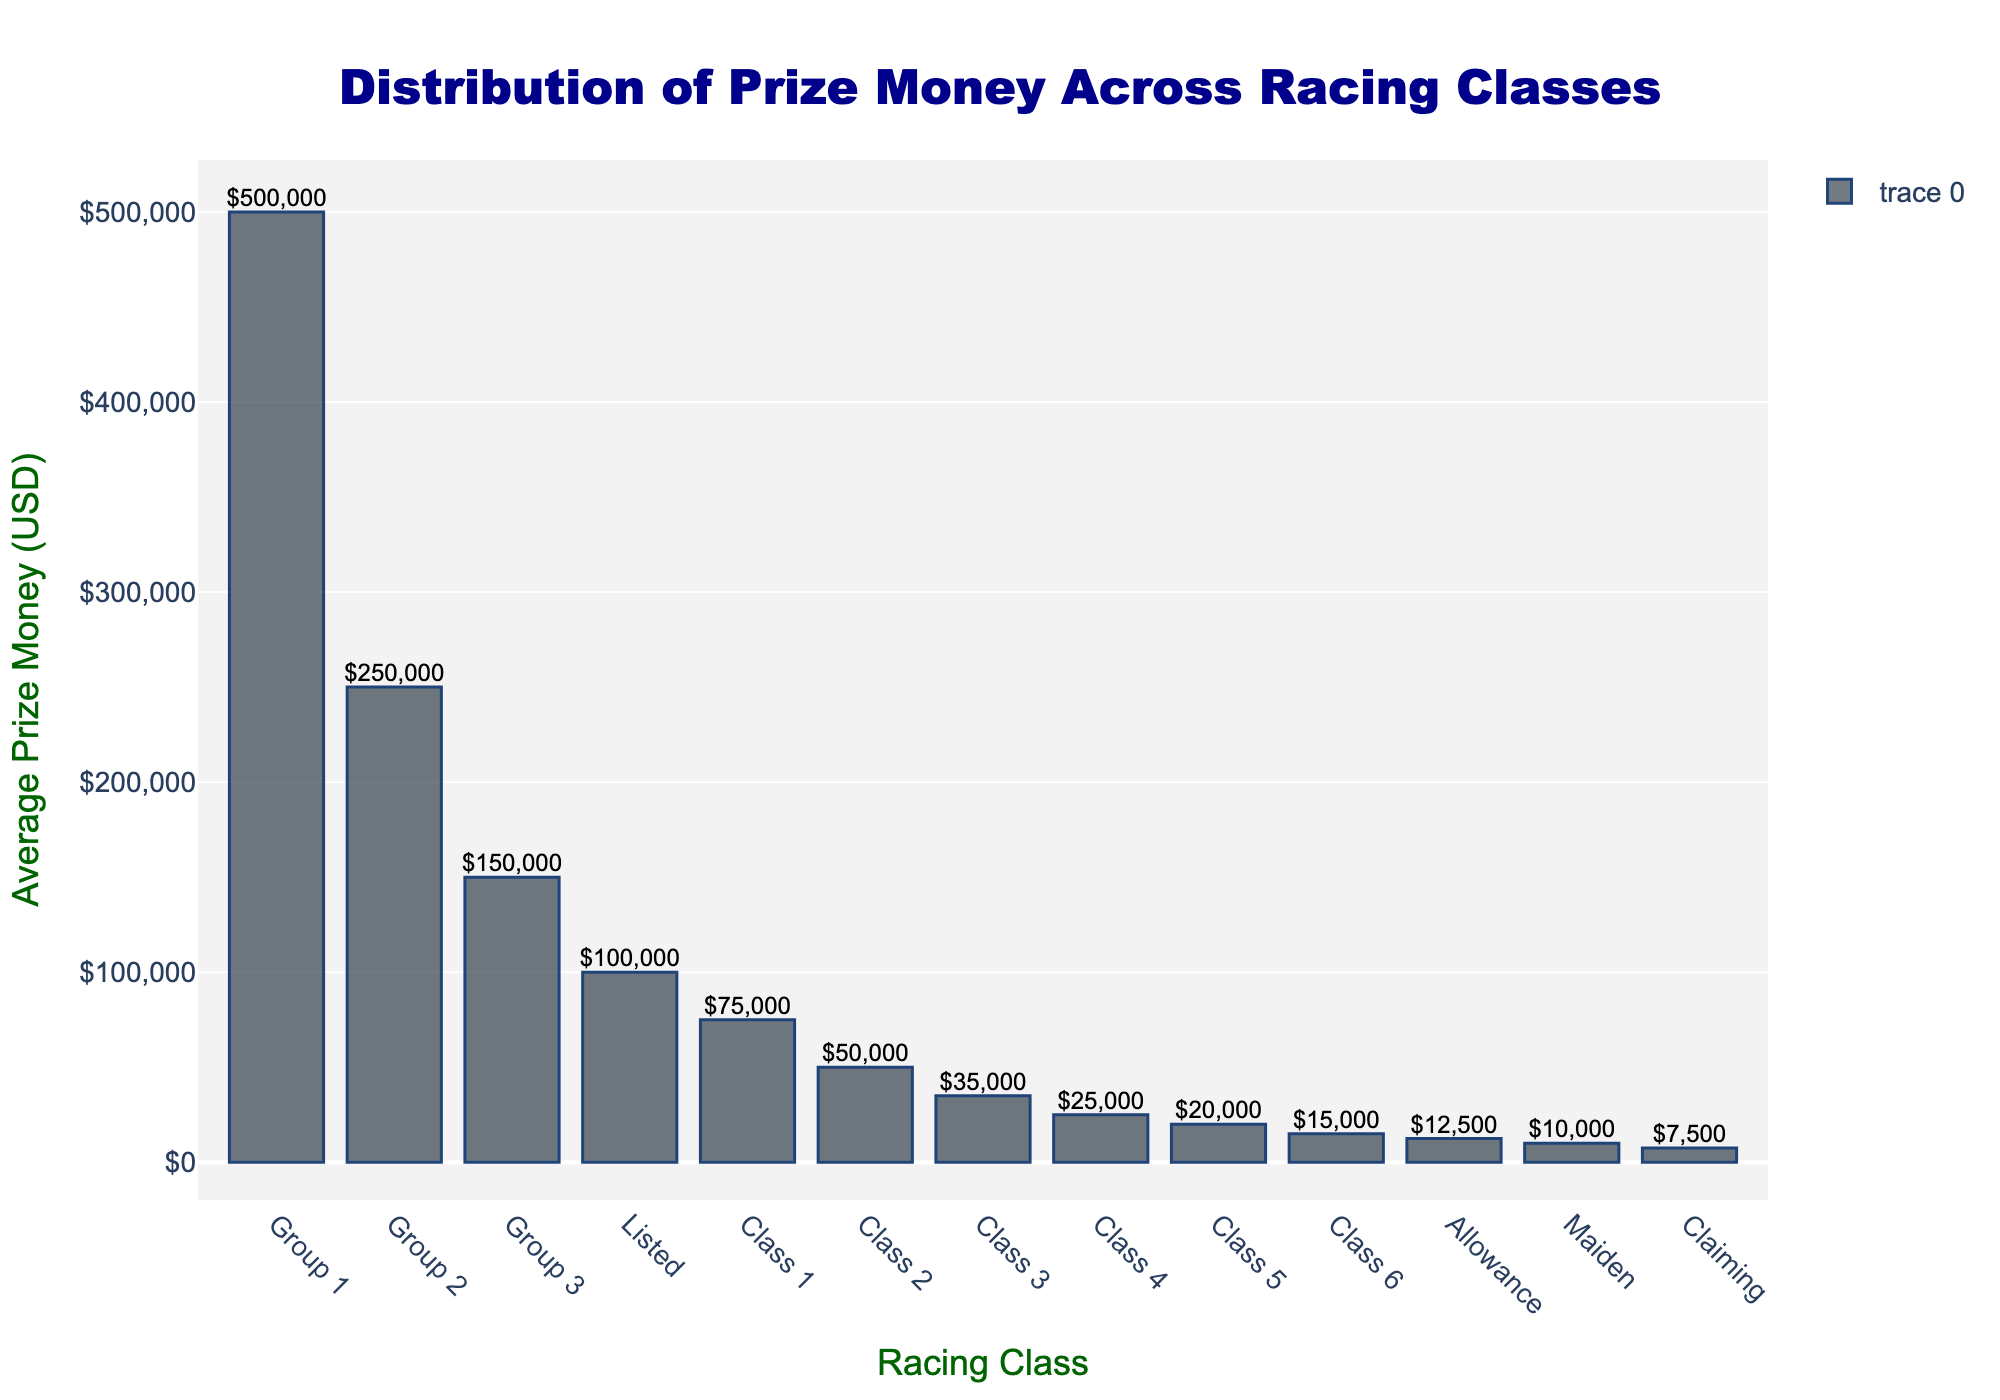Which racing class has the highest average prize money? Looking at the bar chart, the tallest bar represents the racing class with the highest average prize money. It is labeled "Group 1".
Answer: Group 1 Which two racing classes have the lowest average prize money? Observing the bar chart, the two shortest bars represent the classes with the lowest average prize money. They are labeled "Claiming" and "Maiden".
Answer: Claiming and Maiden What is the difference in average prize money between Group 1 and Group 2? Group 1's average prize money is $500,000, and Group 2's is $250,000. Subtracting these two values: $500,000 - $250,000.
Answer: $250,000 How many racing classes have an average prize money over $100,000? By counting the bars that exceed the $100,000 mark, we see that there are 4 classes: Group 1, Group 2, Group 3, and Listed.
Answer: 4 What is the total average prize money for Class 1, Class 2, and Class 3? Adding the average prize money for Class 1 ($75,000), Class 2 ($50,000), and Class 3 ($35,000): $75,000 + $50,000 + $35,000.
Answer: $160,000 What is the average prize money for Group 3 compared to Class 1? Group 3's average prize money is $150,000 and Class 1's is $75,000. Dividing these values: $150,000 / $75,000.
Answer: 2 times Are there more classes with average prize money below $50,000 or above $100,000? Count the number of classes below $50,000 (Class 2, Class 3, Class 4, Class 5, Class 6, Maiden, Claiming, Allowance) and above $100,000 (Group 1, Group 2, Group 3, Listed). 8 classes are below $50,000 and 4 are above $100,000.
Answer: Below $50,000 Which group has the closest average prize money to Class 4? Class 4 has an average prize money of $25,000. The group with the closest average prize money is Class 3 with $35,000, closest than Class 5 ($20,000).
Answer: Class 3 How does the average prize money of Allowance compare to Maiden and Claiming? Allowance has an average prize money of $12,500. Maiden and Claiming have $10,000 and $7,500 respectively. Allowance is higher compared to both.
Answer: Allowance is higher What percent of Group 1's average prize money is Listed's average prize money? Listed's average prize money is $100,000, and Group 1's is $500,000. The percentage is calculated as ($100,000 / $500,000) * 100.
Answer: 20% 